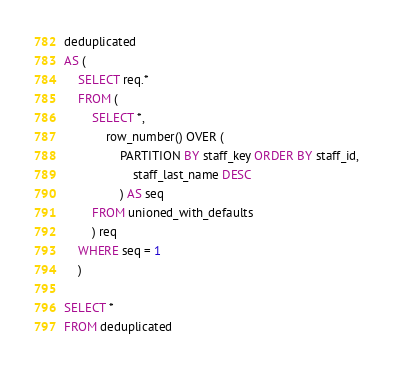<code> <loc_0><loc_0><loc_500><loc_500><_SQL_>deduplicated
AS (
	SELECT req.*
	FROM (
		SELECT *,
			row_number() OVER (
				PARTITION BY staff_key ORDER BY staff_id,
					staff_last_name DESC
				) AS seq
		FROM unioned_with_defaults
		) req
	WHERE seq = 1
	)

SELECT *
FROM deduplicated
</code> 